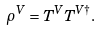Convert formula to latex. <formula><loc_0><loc_0><loc_500><loc_500>\rho ^ { V } = { T } ^ { V } { T } ^ { V \dagger } .</formula> 